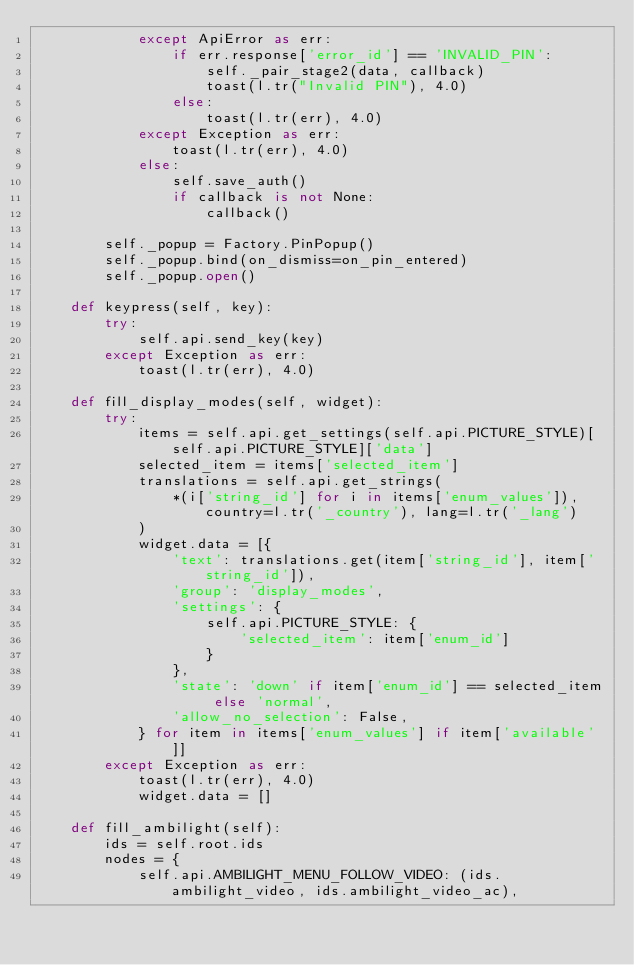<code> <loc_0><loc_0><loc_500><loc_500><_Python_>            except ApiError as err:
                if err.response['error_id'] == 'INVALID_PIN':
                    self._pair_stage2(data, callback)
                    toast(l.tr("Invalid PIN"), 4.0)
                else:
                    toast(l.tr(err), 4.0)
            except Exception as err:
                toast(l.tr(err), 4.0)
            else:
                self.save_auth()
                if callback is not None:
                    callback()

        self._popup = Factory.PinPopup()
        self._popup.bind(on_dismiss=on_pin_entered)
        self._popup.open()

    def keypress(self, key):
        try:
            self.api.send_key(key)
        except Exception as err:
            toast(l.tr(err), 4.0)

    def fill_display_modes(self, widget):
        try:
            items = self.api.get_settings(self.api.PICTURE_STYLE)[self.api.PICTURE_STYLE]['data']
            selected_item = items['selected_item']
            translations = self.api.get_strings(
                *(i['string_id'] for i in items['enum_values']), country=l.tr('_country'), lang=l.tr('_lang')
            )
            widget.data = [{
                'text': translations.get(item['string_id'], item['string_id']),
                'group': 'display_modes',
                'settings': {
                    self.api.PICTURE_STYLE: {
                        'selected_item': item['enum_id']
                    }
                },
                'state': 'down' if item['enum_id'] == selected_item else 'normal',
                'allow_no_selection': False,
            } for item in items['enum_values'] if item['available']]
        except Exception as err:
            toast(l.tr(err), 4.0)
            widget.data = []

    def fill_ambilight(self):
        ids = self.root.ids
        nodes = {
            self.api.AMBILIGHT_MENU_FOLLOW_VIDEO: (ids.ambilight_video, ids.ambilight_video_ac),</code> 